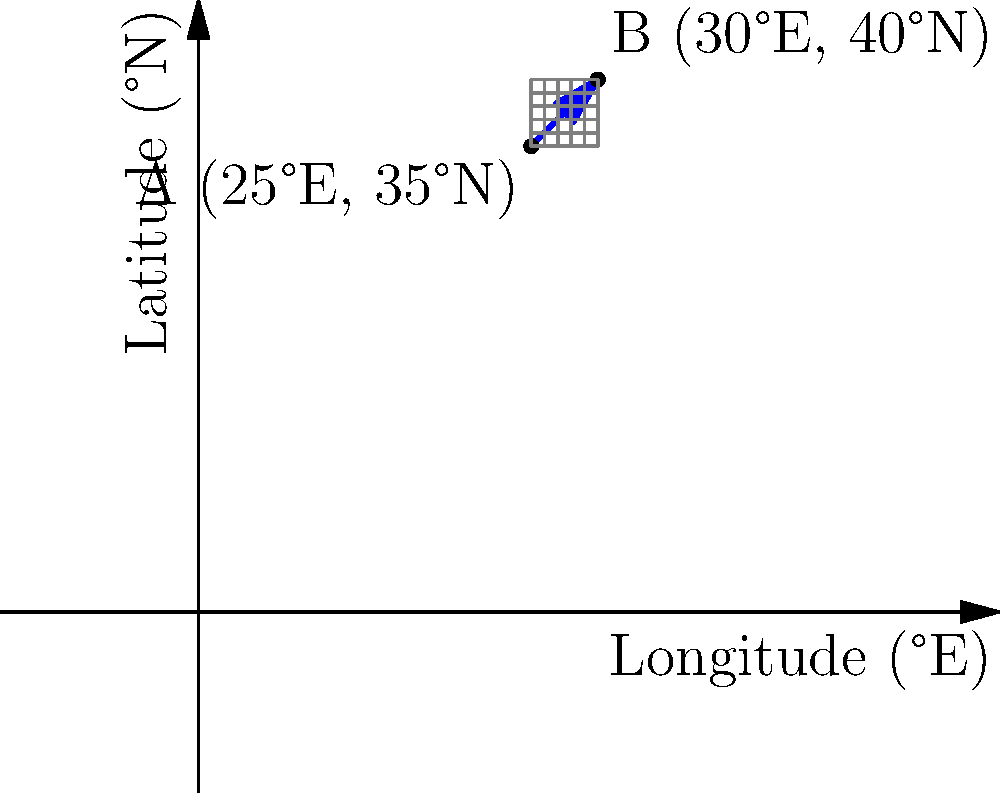During your cruise on the M/S Megastar Aries, the ship traveled from point A (25°E, 35°N) to point B (30°E, 40°N). Calculate the slope of the ship's path between these two points on the map. Express your answer as a decimal rounded to two decimal places. To find the slope of the cruise ship's path, we'll use the slope formula:

$$ \text{slope} = \frac{\text{change in y}}{\text{change in x}} = \frac{y_2 - y_1}{x_2 - x_1} $$

Where $(x_1, y_1)$ is the starting point A, and $(x_2, y_2)$ is the ending point B.

Step 1: Identify the coordinates
- Point A: $(x_1, y_1) = (25, 35)$
- Point B: $(x_2, y_2) = (30, 40)$

Step 2: Calculate the change in y (latitude)
$\Delta y = y_2 - y_1 = 40 - 35 = 5$

Step 3: Calculate the change in x (longitude)
$\Delta x = x_2 - x_1 = 30 - 25 = 5$

Step 4: Apply the slope formula
$$ \text{slope} = \frac{\Delta y}{\Delta x} = \frac{5}{5} = 1 $$

Step 5: Round to two decimal places
The slope is already a whole number, so no rounding is necessary.

Therefore, the slope of the cruise ship's path is 1.00.
Answer: 1.00 